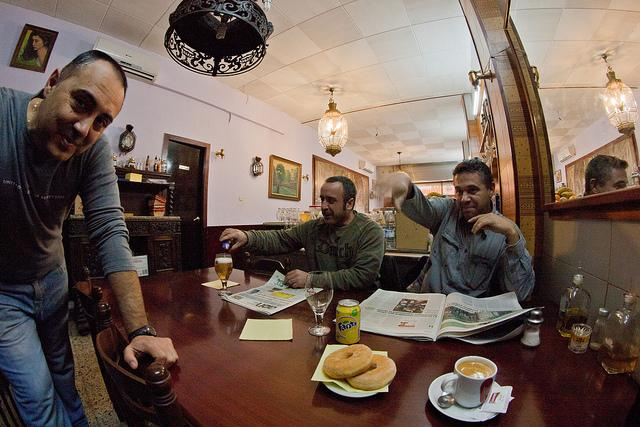How does the person in the image tell time? Please explain your reasoning. wrist watch. The man is wearing a wristwatch. 